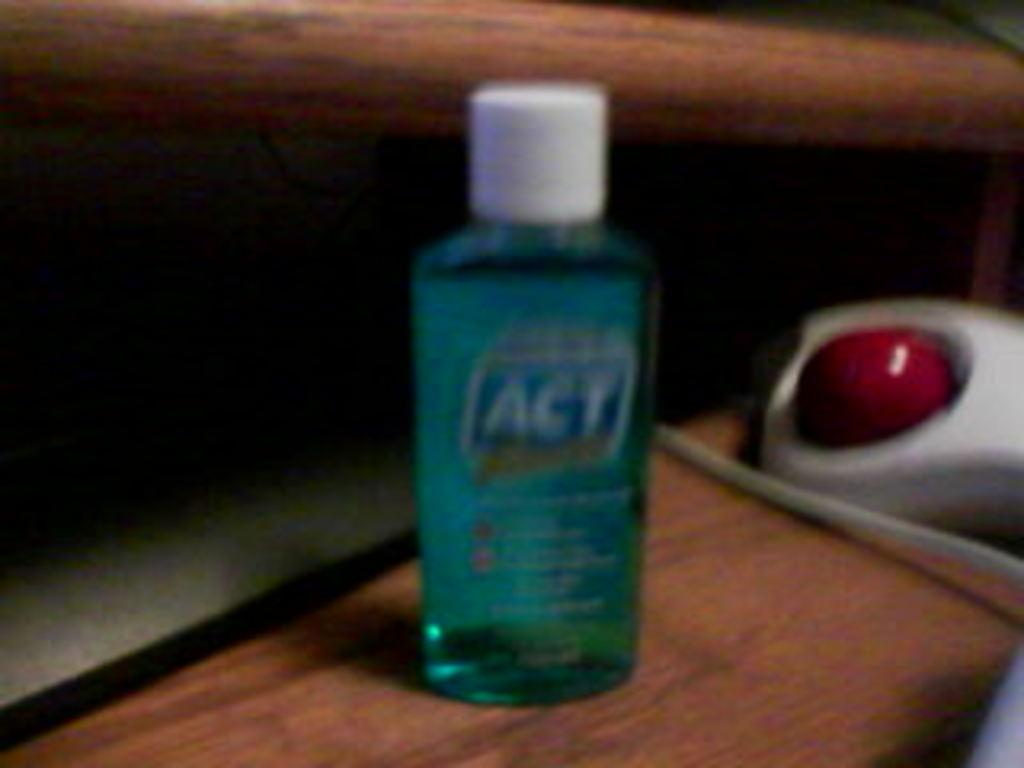<image>
Provide a brief description of the given image. a bottle of ACT on a wooden table 